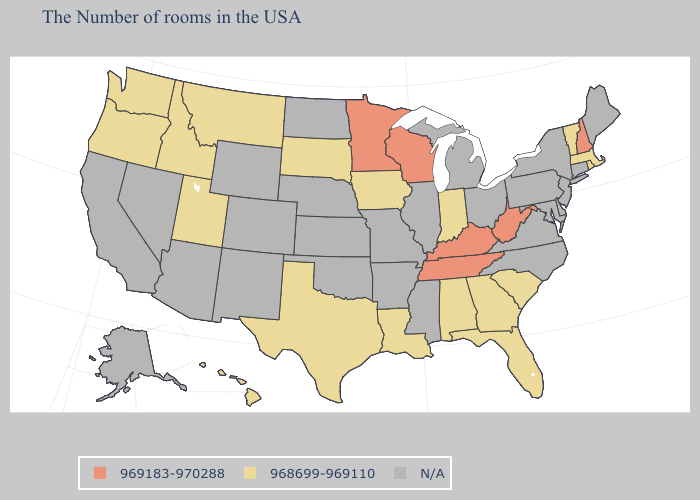What is the highest value in states that border Wisconsin?
Concise answer only. 969183-970288. Name the states that have a value in the range 969183-970288?
Be succinct. New Hampshire, West Virginia, Kentucky, Tennessee, Wisconsin, Minnesota. What is the value of Texas?
Keep it brief. 968699-969110. Among the states that border Arizona , which have the highest value?
Keep it brief. Utah. What is the value of Illinois?
Be succinct. N/A. Does Wisconsin have the highest value in the USA?
Keep it brief. Yes. Name the states that have a value in the range 969183-970288?
Be succinct. New Hampshire, West Virginia, Kentucky, Tennessee, Wisconsin, Minnesota. What is the value of Alaska?
Be succinct. N/A. Does the first symbol in the legend represent the smallest category?
Answer briefly. No. Does the first symbol in the legend represent the smallest category?
Give a very brief answer. No. Which states have the lowest value in the USA?
Write a very short answer. Massachusetts, Rhode Island, Vermont, South Carolina, Florida, Georgia, Indiana, Alabama, Louisiana, Iowa, Texas, South Dakota, Utah, Montana, Idaho, Washington, Oregon, Hawaii. Is the legend a continuous bar?
Be succinct. No. What is the highest value in states that border Massachusetts?
Quick response, please. 969183-970288. What is the value of Maryland?
Write a very short answer. N/A. 